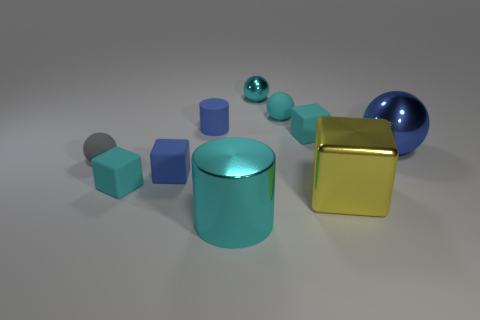There is a large cylinder that is the same color as the small shiny thing; what is its material?
Give a very brief answer. Metal. What material is the blue object that is the same size as the cyan metal cylinder?
Your response must be concise. Metal. How many objects are large yellow shiny blocks or tiny balls?
Your response must be concise. 4. How many tiny cyan matte things are both left of the tiny blue matte cube and right of the large metallic cylinder?
Offer a very short reply. 0. Is the number of yellow objects that are to the right of the yellow shiny cube less than the number of purple metallic cylinders?
Make the answer very short. No. The metallic thing that is the same size as the gray rubber sphere is what shape?
Ensure brevity in your answer.  Sphere. How many other objects are the same color as the large block?
Your response must be concise. 0. Does the yellow metal cube have the same size as the cyan matte ball?
Give a very brief answer. No. How many objects are small blue cubes or objects that are left of the blue rubber cylinder?
Make the answer very short. 3. Are there fewer matte cubes that are in front of the large yellow object than gray matte objects that are behind the matte cylinder?
Keep it short and to the point. No. 